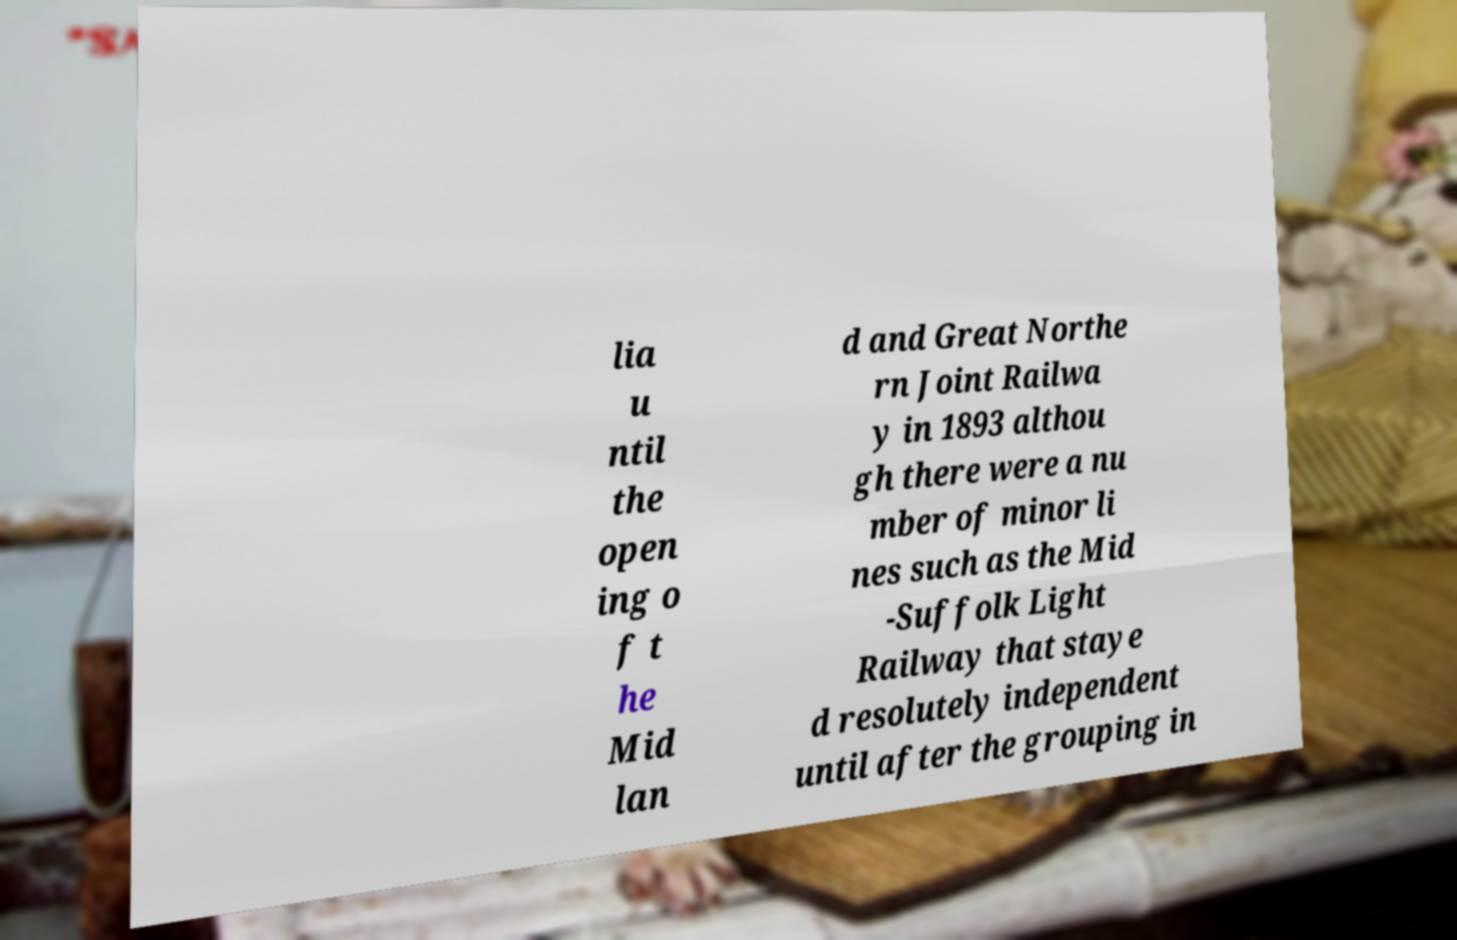For documentation purposes, I need the text within this image transcribed. Could you provide that? lia u ntil the open ing o f t he Mid lan d and Great Northe rn Joint Railwa y in 1893 althou gh there were a nu mber of minor li nes such as the Mid -Suffolk Light Railway that staye d resolutely independent until after the grouping in 